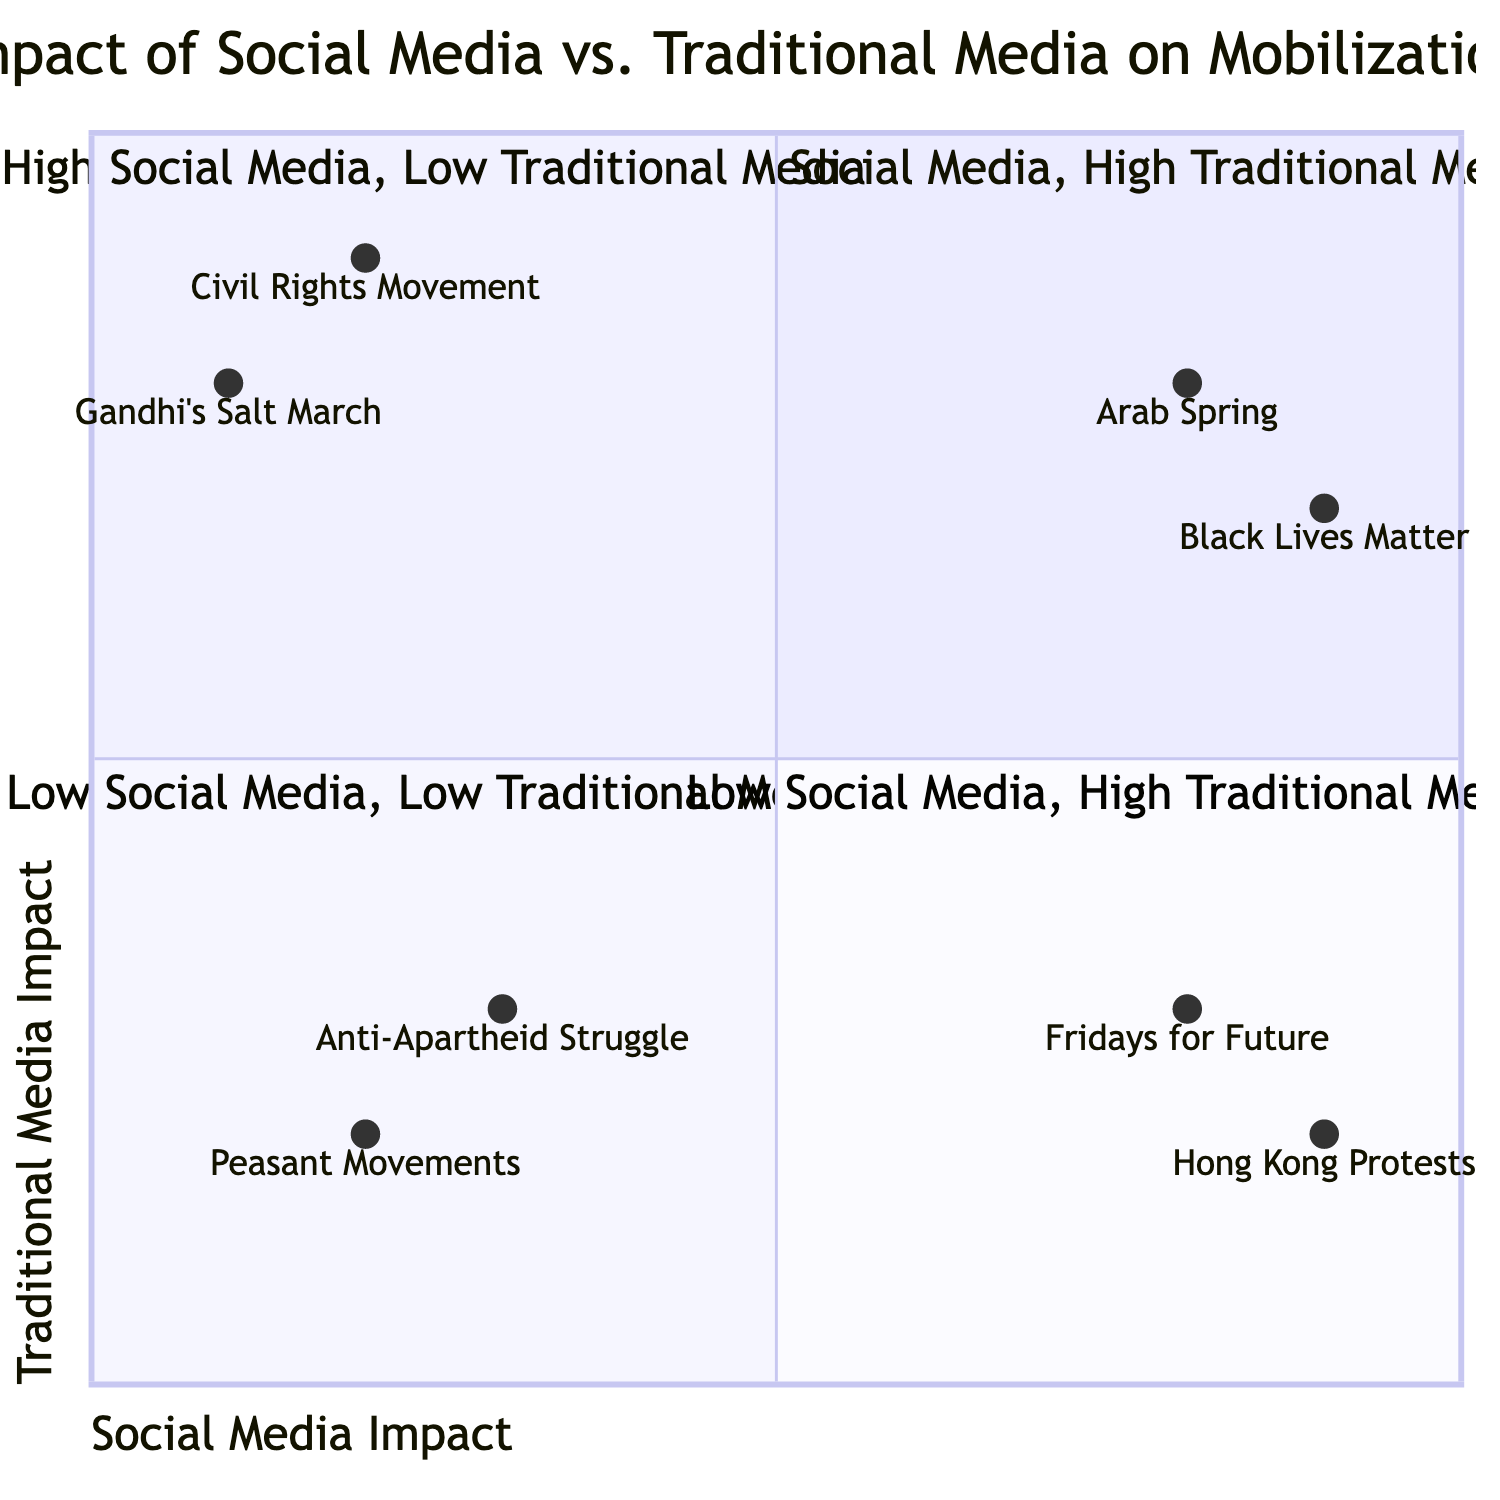What country is associated with the Arab Spring? The diagram indicates that the Arab Spring is associated with Egypt and Tunisia. These countries are listed under the "High Social Media, High Traditional Media" quadrant due to their significant use of both types of media during mobilization efforts.
Answer: Egypt, Tunisia Which movement has the highest impact of social media? By examining the coordinates of the movements in the quadrant, the Hong Kong Protests and Fridays for Future are both high on social media impact; however, the Hong Kong Protests have the highest value of 0.9 on the x-axis.
Answer: Hong Kong Protests What is the social media impact value for Gandhi's Salt March? The coordinates for Gandhi's Salt March show a social media impact value of 0.1 on the x-axis, which indicates a low reliance on social media during the mobilization.
Answer: 0.1 How many movements are in the "Low Social Media, Low Traditional Media" quadrant? The diagram lists two movements in this quadrant: Peasant Movements and Anti-Apartheid Struggle, thus the total count is two movements.
Answer: 2 Which quadrant has only movements with limited media engagement? The "Low Social Media, Low Traditional Media" quadrant contains movements that demonstrate low engagement levels with both types of media, indicating minimal use in their mobilization efforts.
Answer: Low Social Media, Low Traditional Media Which movement is predominantly driven by traditional media? The Civil Rights Movement is labeled as predominantly driven by traditional media, with a high impact value of 0.9 on the y-axis, which indicates significant reliance on traditional media channels for mobilization.
Answer: Civil Rights Movement What is the social media impact of Black Lives Matter? Black Lives Matter is represented in the quadrant with a social media impact value of 0.9, making it one of the highest on the x-axis.
Answer: 0.9 Identify the movement that primarily utilized social media with minimal traditional media support. The Hong Kong Protests fall into this category as they exhibit a high impact on social media (0.9) but a low impact on traditional media (0.2), indicating reliance on social media for organization.
Answer: Hong Kong Protests 